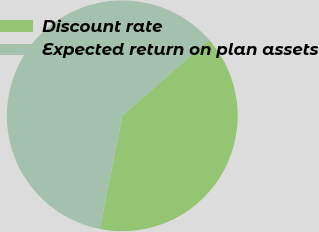Convert chart to OTSL. <chart><loc_0><loc_0><loc_500><loc_500><pie_chart><fcel>Discount rate<fcel>Expected return on plan assets<nl><fcel>39.59%<fcel>60.41%<nl></chart> 